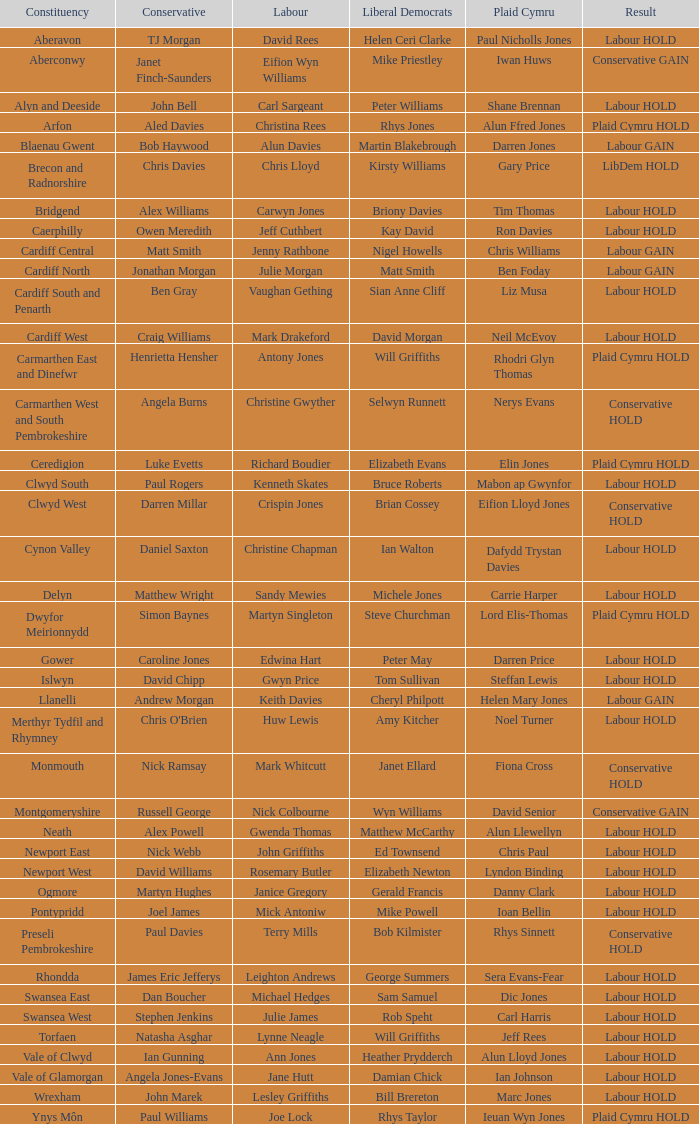In what electoral area was the result labour retain and liberal democrat elizabeth newton succeeded? Newport West. 